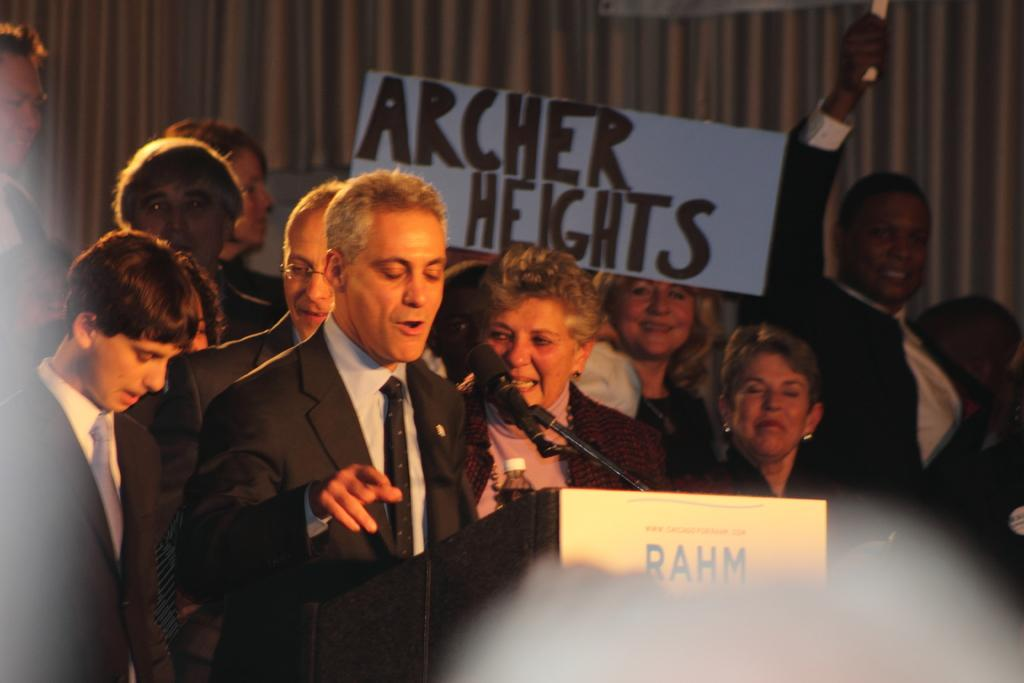What is the man in the image doing? The man is talking on a microphone. What is the man wearing in the image? The man is wearing a black suit. What can be seen in the background of the image? There are many people in the background of the image. What is on the wall in the middle of the image? There is a banner on a wall in the middle of the image. What type of noise is the man making while talking on the microphone? The image does not provide information about the noise level or type of noise the man is making while talking on the microphone. 